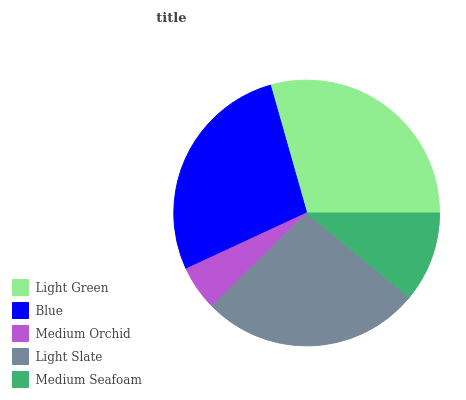Is Medium Orchid the minimum?
Answer yes or no. Yes. Is Light Green the maximum?
Answer yes or no. Yes. Is Blue the minimum?
Answer yes or no. No. Is Blue the maximum?
Answer yes or no. No. Is Light Green greater than Blue?
Answer yes or no. Yes. Is Blue less than Light Green?
Answer yes or no. Yes. Is Blue greater than Light Green?
Answer yes or no. No. Is Light Green less than Blue?
Answer yes or no. No. Is Light Slate the high median?
Answer yes or no. Yes. Is Light Slate the low median?
Answer yes or no. Yes. Is Medium Orchid the high median?
Answer yes or no. No. Is Blue the low median?
Answer yes or no. No. 